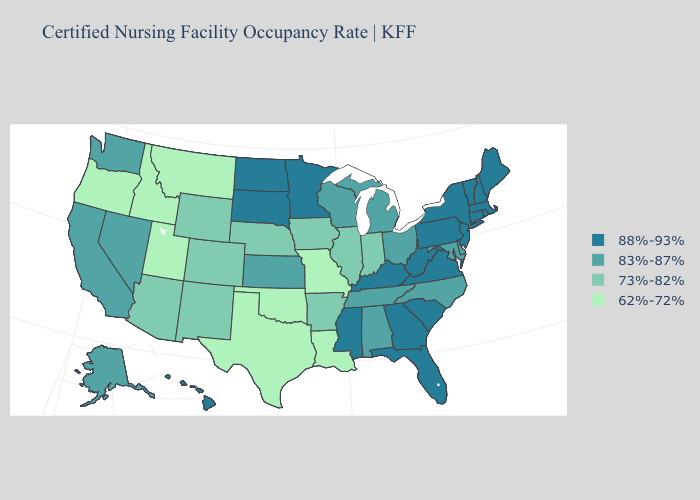Is the legend a continuous bar?
Be succinct. No. Which states hav the highest value in the South?
Write a very short answer. Florida, Georgia, Kentucky, Mississippi, South Carolina, Virginia, West Virginia. What is the highest value in the South ?
Quick response, please. 88%-93%. Does North Dakota have the lowest value in the USA?
Give a very brief answer. No. What is the value of Missouri?
Answer briefly. 62%-72%. Name the states that have a value in the range 83%-87%?
Be succinct. Alabama, Alaska, California, Delaware, Kansas, Maryland, Michigan, Nevada, North Carolina, Ohio, Tennessee, Washington, Wisconsin. Does Delaware have a higher value than North Dakota?
Answer briefly. No. Name the states that have a value in the range 83%-87%?
Answer briefly. Alabama, Alaska, California, Delaware, Kansas, Maryland, Michigan, Nevada, North Carolina, Ohio, Tennessee, Washington, Wisconsin. Does the map have missing data?
Short answer required. No. Name the states that have a value in the range 73%-82%?
Concise answer only. Arizona, Arkansas, Colorado, Illinois, Indiana, Iowa, Nebraska, New Mexico, Wyoming. Among the states that border California , does Nevada have the highest value?
Concise answer only. Yes. What is the value of Florida?
Be succinct. 88%-93%. What is the value of Colorado?
Short answer required. 73%-82%. What is the value of Maryland?
Be succinct. 83%-87%. Among the states that border Louisiana , which have the highest value?
Answer briefly. Mississippi. 